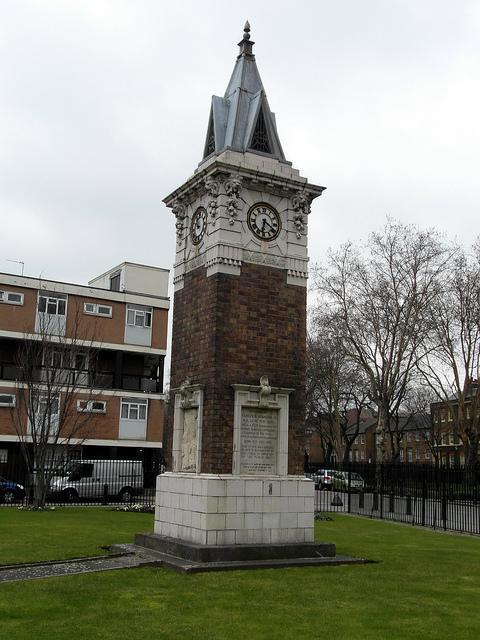What color are the square bricks outlining the base of this small clock tower?
Answer the question by selecting the correct answer among the 4 following choices and explain your choice with a short sentence. The answer should be formatted with the following format: `Answer: choice
Rationale: rationale.`
Options: Red, tan, black, white. Answer: white.
Rationale: The other bricks are red. the square bricks at the base do not match the other bricks and are not black or tan. 